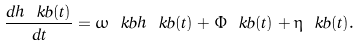<formula> <loc_0><loc_0><loc_500><loc_500>\frac { d \hat { h } _ { \ } k b ( t ) } { d t } = \omega _ { \ } k b \hat { h } _ { \ } k b ( t ) + \hat { \Phi } _ { \ } k b ( t ) + \hat { \eta } _ { \ } k b ( t ) .</formula> 